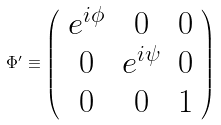<formula> <loc_0><loc_0><loc_500><loc_500>\Phi ^ { \prime } \equiv \left ( \begin{array} { c c c } e ^ { i \phi } & 0 & 0 \\ 0 & e ^ { i \psi } & 0 \\ 0 & 0 & 1 \end{array} \right )</formula> 